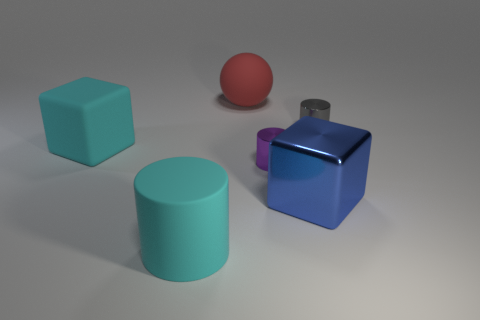Add 3 large purple cylinders. How many objects exist? 9 Subtract all balls. How many objects are left? 5 Add 6 large red rubber things. How many large red rubber things exist? 7 Subtract 1 red spheres. How many objects are left? 5 Subtract all big cyan matte blocks. Subtract all large yellow things. How many objects are left? 5 Add 6 purple objects. How many purple objects are left? 7 